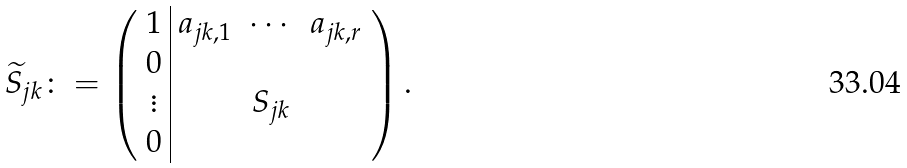<formula> <loc_0><loc_0><loc_500><loc_500>\widetilde { S } _ { j k } \colon = \left ( \begin{array} { c | c c c } 1 & a _ { j k , 1 } & \cdots & a _ { j k , r } \\ 0 & & & \\ \vdots & & S _ { j k } & \\ 0 & & & \end{array} \right ) .</formula> 